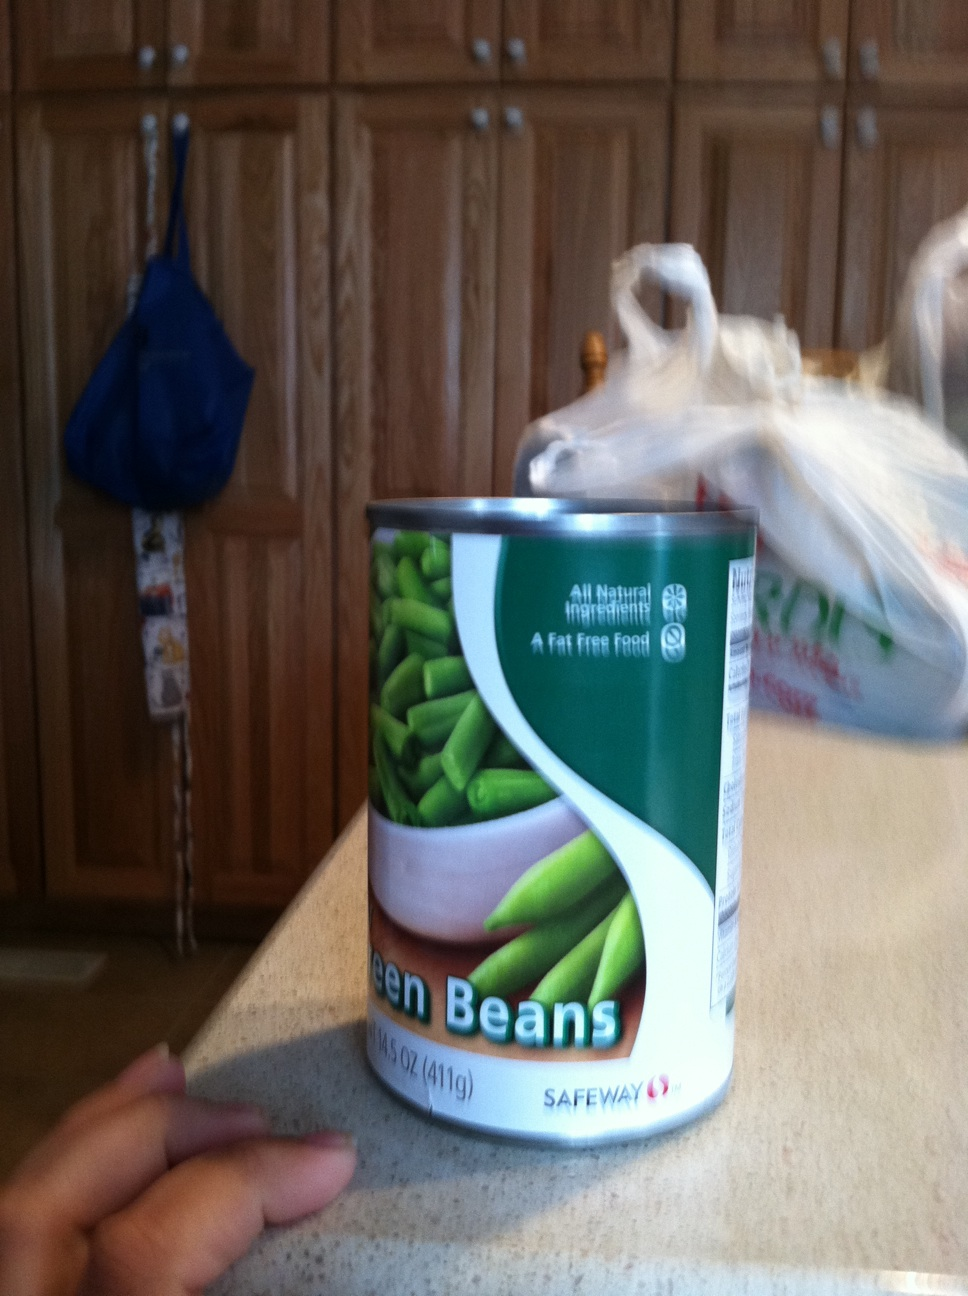What are some cooking tips for using canned green beans? Canned green beans are already cooked, so you can simply heat them before serving. They are great in casseroles, sautéed with garlic and almonds, or tossed in a fresh salad for added crunch and nutrition. Are there any specific recipes that highlight green beans? Absolutely! A popular recipe is green bean casserole, which combines green beans with cream of mushroom soup and crispy fried onions. Another option is to stir-fry them with chili sauce and ground pork for a spicy twist. 